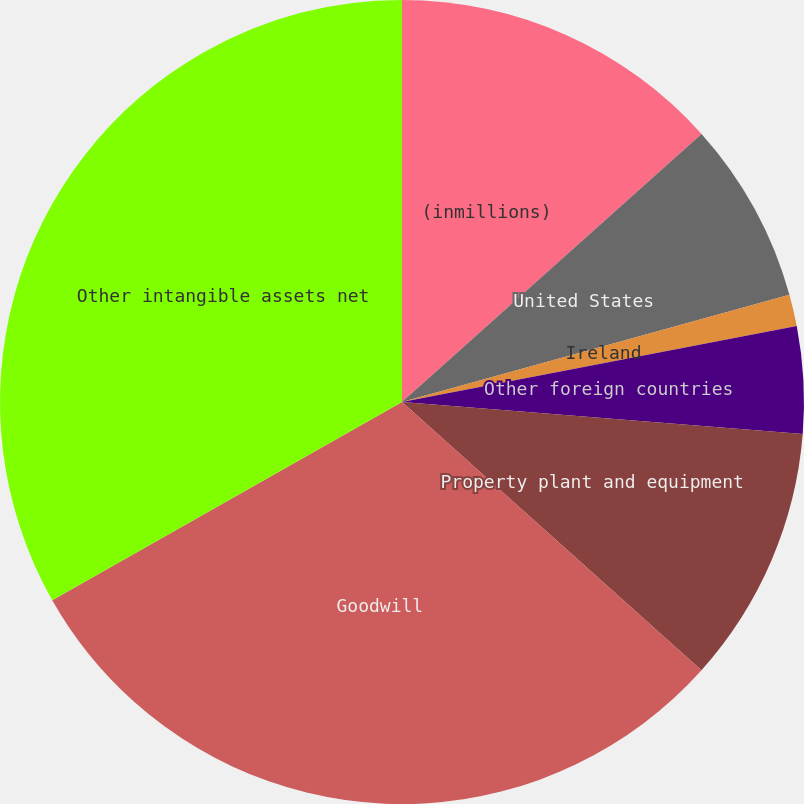<chart> <loc_0><loc_0><loc_500><loc_500><pie_chart><fcel>(inmillions)<fcel>United States<fcel>Ireland<fcel>Other foreign countries<fcel>Property plant and equipment<fcel>Goodwill<fcel>Other intangible assets net<nl><fcel>13.38%<fcel>7.32%<fcel>1.27%<fcel>4.3%<fcel>10.35%<fcel>30.17%<fcel>33.2%<nl></chart> 